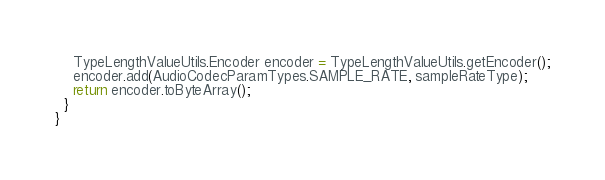Convert code to text. <code><loc_0><loc_0><loc_500><loc_500><_Java_>    TypeLengthValueUtils.Encoder encoder = TypeLengthValueUtils.getEncoder();
    encoder.add(AudioCodecParamTypes.SAMPLE_RATE, sampleRateType);
    return encoder.toByteArray();
  }
}
</code> 